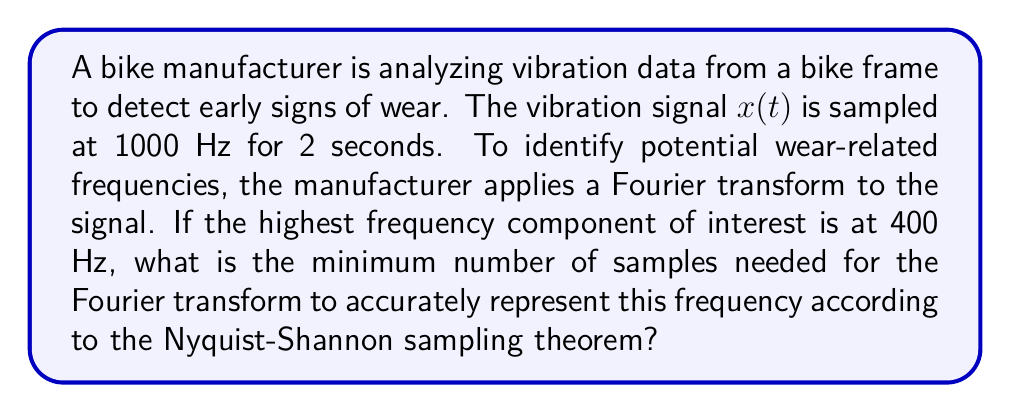Can you solve this math problem? To solve this problem, we need to apply the Nyquist-Shannon sampling theorem and consider the given information:

1. The sampling frequency is 1000 Hz.
2. The highest frequency of interest is 400 Hz.
3. The total sampling duration is 2 seconds.

The Nyquist-Shannon sampling theorem states that to accurately represent a signal, the sampling frequency must be at least twice the highest frequency component in the signal. This minimum sampling frequency is called the Nyquist rate.

Given:
- Sampling frequency: $f_s = 1000$ Hz
- Highest frequency of interest: $f_{max} = 400$ Hz

Step 1: Check if the sampling frequency satisfies the Nyquist-Shannon theorem.
Nyquist rate = $2 \times f_{max} = 2 \times 400 = 800$ Hz
Since $f_s (1000 \text{ Hz}) > 800 \text{ Hz}$, the sampling frequency is sufficient.

Step 2: Calculate the number of samples taken in 2 seconds.
Number of samples = Sampling frequency × Duration
$$N = f_s \times t = 1000 \text{ Hz} \times 2 \text{ s} = 2000 \text{ samples}$$

Step 3: Determine the frequency resolution of the Fourier transform.
Frequency resolution = $\frac{f_s}{N} = \frac{1000 \text{ Hz}}{2000} = 0.5 \text{ Hz}$

Step 4: Calculate the minimum number of samples needed to represent 400 Hz.
Minimum number of samples = $\frac{2 \times f_{max}}{f_s} \times N$
$$N_{min} = \frac{2 \times 400 \text{ Hz}}{1000 \text{ Hz}} \times 2000 = 1600 \text{ samples}$$

Therefore, the minimum number of samples needed for the Fourier transform to accurately represent the 400 Hz frequency component is 1600 samples.
Answer: 1600 samples 